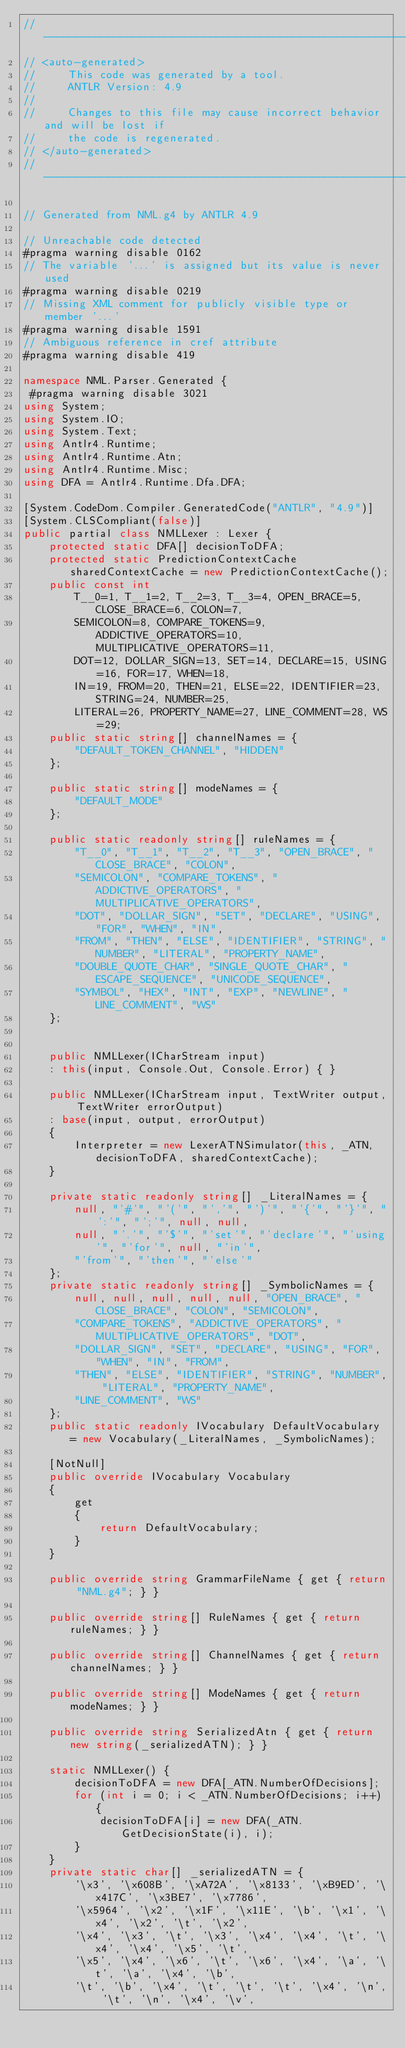<code> <loc_0><loc_0><loc_500><loc_500><_C#_>//------------------------------------------------------------------------------
// <auto-generated>
//     This code was generated by a tool.
//     ANTLR Version: 4.9
//
//     Changes to this file may cause incorrect behavior and will be lost if
//     the code is regenerated.
// </auto-generated>
//------------------------------------------------------------------------------

// Generated from NML.g4 by ANTLR 4.9

// Unreachable code detected
#pragma warning disable 0162
// The variable '...' is assigned but its value is never used
#pragma warning disable 0219
// Missing XML comment for publicly visible type or member '...'
#pragma warning disable 1591
// Ambiguous reference in cref attribute
#pragma warning disable 419

namespace NML.Parser.Generated {
 #pragma warning disable 3021 
using System;
using System.IO;
using System.Text;
using Antlr4.Runtime;
using Antlr4.Runtime.Atn;
using Antlr4.Runtime.Misc;
using DFA = Antlr4.Runtime.Dfa.DFA;

[System.CodeDom.Compiler.GeneratedCode("ANTLR", "4.9")]
[System.CLSCompliant(false)]
public partial class NMLLexer : Lexer {
	protected static DFA[] decisionToDFA;
	protected static PredictionContextCache sharedContextCache = new PredictionContextCache();
	public const int
		T__0=1, T__1=2, T__2=3, T__3=4, OPEN_BRACE=5, CLOSE_BRACE=6, COLON=7, 
		SEMICOLON=8, COMPARE_TOKENS=9, ADDICTIVE_OPERATORS=10, MULTIPLICATIVE_OPERATORS=11, 
		DOT=12, DOLLAR_SIGN=13, SET=14, DECLARE=15, USING=16, FOR=17, WHEN=18, 
		IN=19, FROM=20, THEN=21, ELSE=22, IDENTIFIER=23, STRING=24, NUMBER=25, 
		LITERAL=26, PROPERTY_NAME=27, LINE_COMMENT=28, WS=29;
	public static string[] channelNames = {
		"DEFAULT_TOKEN_CHANNEL", "HIDDEN"
	};

	public static string[] modeNames = {
		"DEFAULT_MODE"
	};

	public static readonly string[] ruleNames = {
		"T__0", "T__1", "T__2", "T__3", "OPEN_BRACE", "CLOSE_BRACE", "COLON", 
		"SEMICOLON", "COMPARE_TOKENS", "ADDICTIVE_OPERATORS", "MULTIPLICATIVE_OPERATORS", 
		"DOT", "DOLLAR_SIGN", "SET", "DECLARE", "USING", "FOR", "WHEN", "IN", 
		"FROM", "THEN", "ELSE", "IDENTIFIER", "STRING", "NUMBER", "LITERAL", "PROPERTY_NAME", 
		"DOUBLE_QUOTE_CHAR", "SINGLE_QUOTE_CHAR", "ESCAPE_SEQUENCE", "UNICODE_SEQUENCE", 
		"SYMBOL", "HEX", "INT", "EXP", "NEWLINE", "LINE_COMMENT", "WS"
	};


	public NMLLexer(ICharStream input)
	: this(input, Console.Out, Console.Error) { }

	public NMLLexer(ICharStream input, TextWriter output, TextWriter errorOutput)
	: base(input, output, errorOutput)
	{
		Interpreter = new LexerATNSimulator(this, _ATN, decisionToDFA, sharedContextCache);
	}

	private static readonly string[] _LiteralNames = {
		null, "'#'", "'('", "','", "')'", "'{'", "'}'", "':'", "';'", null, null, 
		null, "'.'", "'$'", "'set'", "'declare'", "'using'", "'for'", null, "'in'", 
		"'from'", "'then'", "'else'"
	};
	private static readonly string[] _SymbolicNames = {
		null, null, null, null, null, "OPEN_BRACE", "CLOSE_BRACE", "COLON", "SEMICOLON", 
		"COMPARE_TOKENS", "ADDICTIVE_OPERATORS", "MULTIPLICATIVE_OPERATORS", "DOT", 
		"DOLLAR_SIGN", "SET", "DECLARE", "USING", "FOR", "WHEN", "IN", "FROM", 
		"THEN", "ELSE", "IDENTIFIER", "STRING", "NUMBER", "LITERAL", "PROPERTY_NAME", 
		"LINE_COMMENT", "WS"
	};
	public static readonly IVocabulary DefaultVocabulary = new Vocabulary(_LiteralNames, _SymbolicNames);

	[NotNull]
	public override IVocabulary Vocabulary
	{
		get
		{
			return DefaultVocabulary;
		}
	}

	public override string GrammarFileName { get { return "NML.g4"; } }

	public override string[] RuleNames { get { return ruleNames; } }

	public override string[] ChannelNames { get { return channelNames; } }

	public override string[] ModeNames { get { return modeNames; } }

	public override string SerializedAtn { get { return new string(_serializedATN); } }

	static NMLLexer() {
		decisionToDFA = new DFA[_ATN.NumberOfDecisions];
		for (int i = 0; i < _ATN.NumberOfDecisions; i++) {
			decisionToDFA[i] = new DFA(_ATN.GetDecisionState(i), i);
		}
	}
	private static char[] _serializedATN = {
		'\x3', '\x608B', '\xA72A', '\x8133', '\xB9ED', '\x417C', '\x3BE7', '\x7786', 
		'\x5964', '\x2', '\x1F', '\x11E', '\b', '\x1', '\x4', '\x2', '\t', '\x2', 
		'\x4', '\x3', '\t', '\x3', '\x4', '\x4', '\t', '\x4', '\x4', '\x5', '\t', 
		'\x5', '\x4', '\x6', '\t', '\x6', '\x4', '\a', '\t', '\a', '\x4', '\b', 
		'\t', '\b', '\x4', '\t', '\t', '\t', '\x4', '\n', '\t', '\n', '\x4', '\v', </code> 